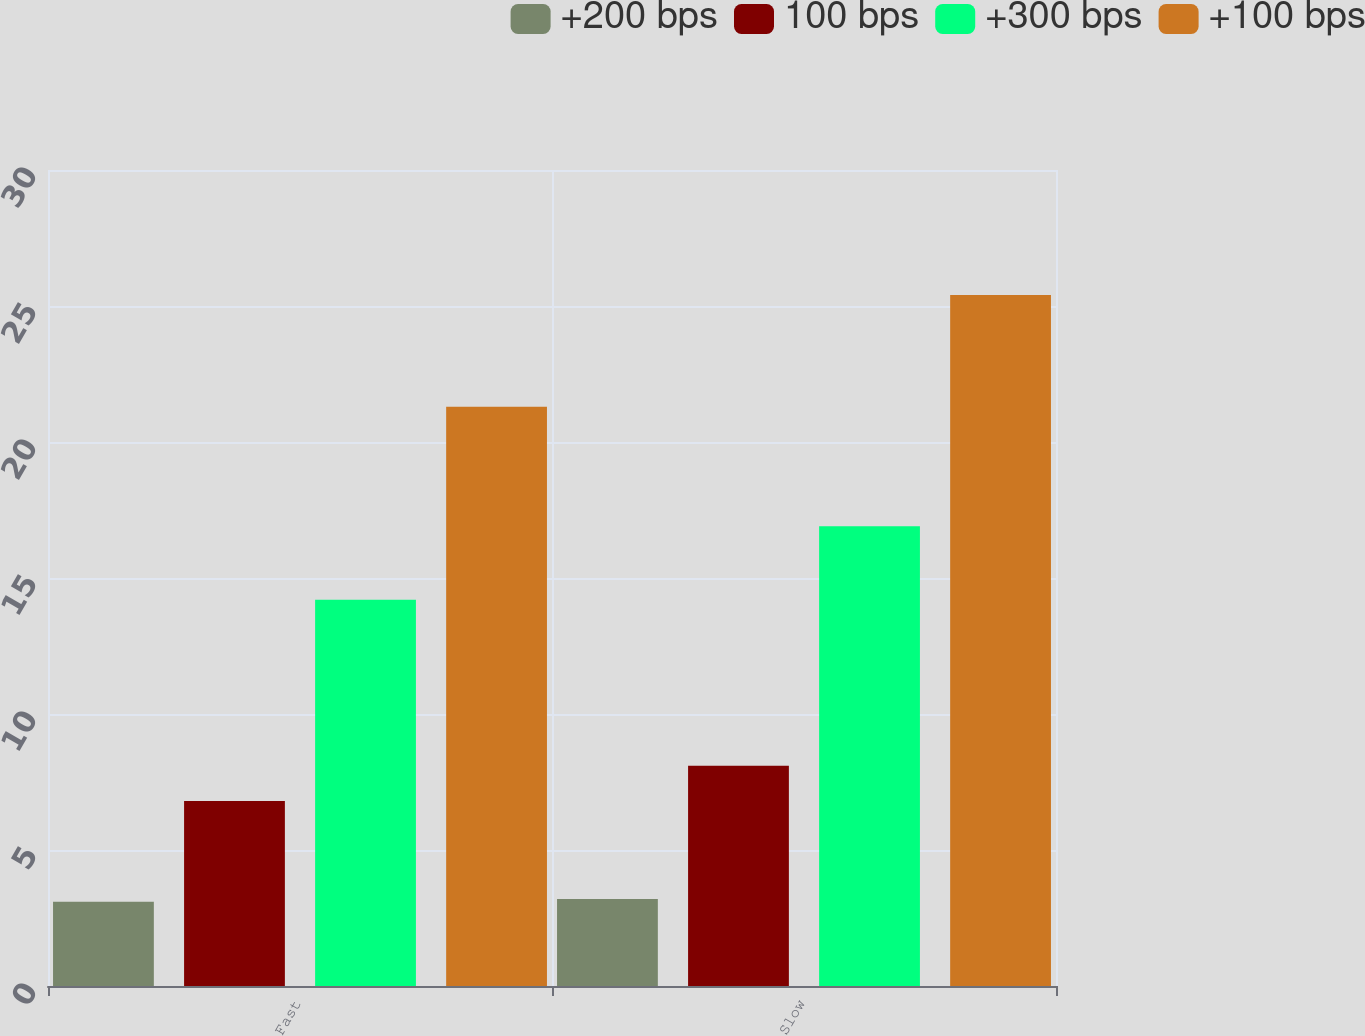<chart> <loc_0><loc_0><loc_500><loc_500><stacked_bar_chart><ecel><fcel>Fast<fcel>Slow<nl><fcel>+200 bps<fcel>3.1<fcel>3.2<nl><fcel>100 bps<fcel>6.8<fcel>8.1<nl><fcel>+300 bps<fcel>14.2<fcel>16.9<nl><fcel>+100 bps<fcel>21.3<fcel>25.4<nl></chart> 